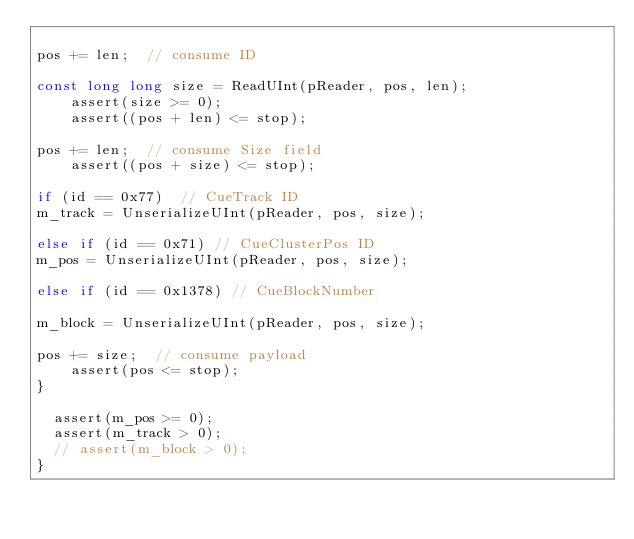<code> <loc_0><loc_0><loc_500><loc_500><_C++_>
pos += len;  // consume ID

const long long size = ReadUInt(pReader, pos, len);
    assert(size >= 0);
    assert((pos + len) <= stop);

pos += len;  // consume Size field
    assert((pos + size) <= stop);

if (id == 0x77)  // CueTrack ID
m_track = UnserializeUInt(pReader, pos, size);

else if (id == 0x71) // CueClusterPos ID
m_pos = UnserializeUInt(pReader, pos, size);

else if (id == 0x1378) // CueBlockNumber

m_block = UnserializeUInt(pReader, pos, size);

pos += size;  // consume payload
    assert(pos <= stop);
}

  assert(m_pos >= 0);
  assert(m_track > 0);
  // assert(m_block > 0);
}
</code> 